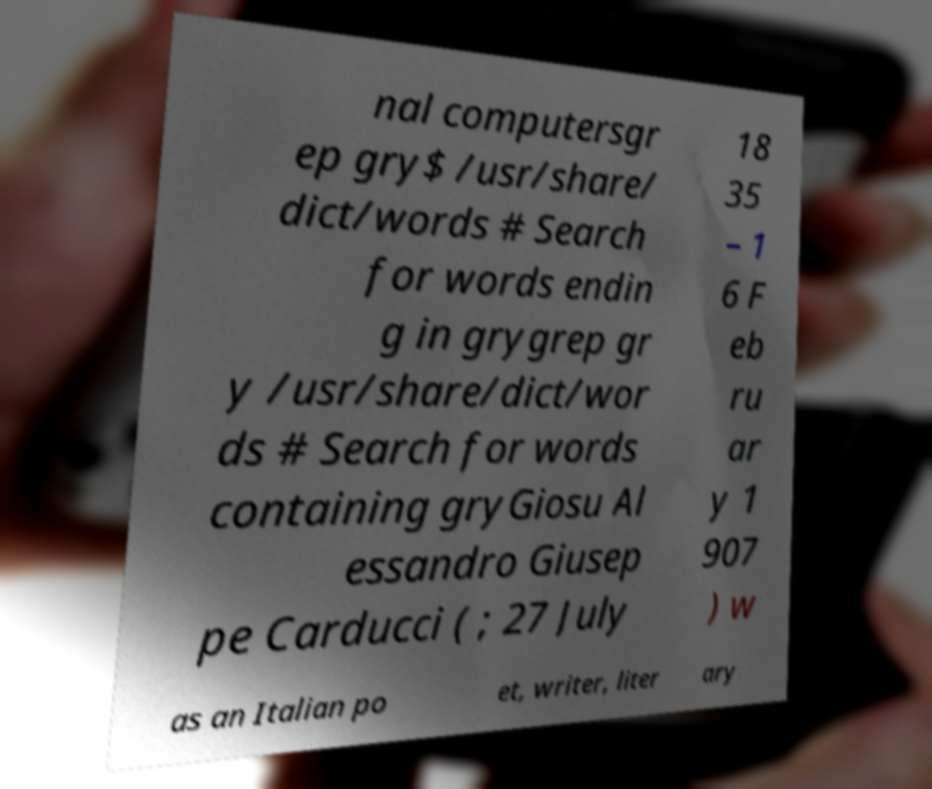I need the written content from this picture converted into text. Can you do that? nal computersgr ep gry$ /usr/share/ dict/words # Search for words endin g in grygrep gr y /usr/share/dict/wor ds # Search for words containing gryGiosu Al essandro Giusep pe Carducci ( ; 27 July 18 35 – 1 6 F eb ru ar y 1 907 ) w as an Italian po et, writer, liter ary 